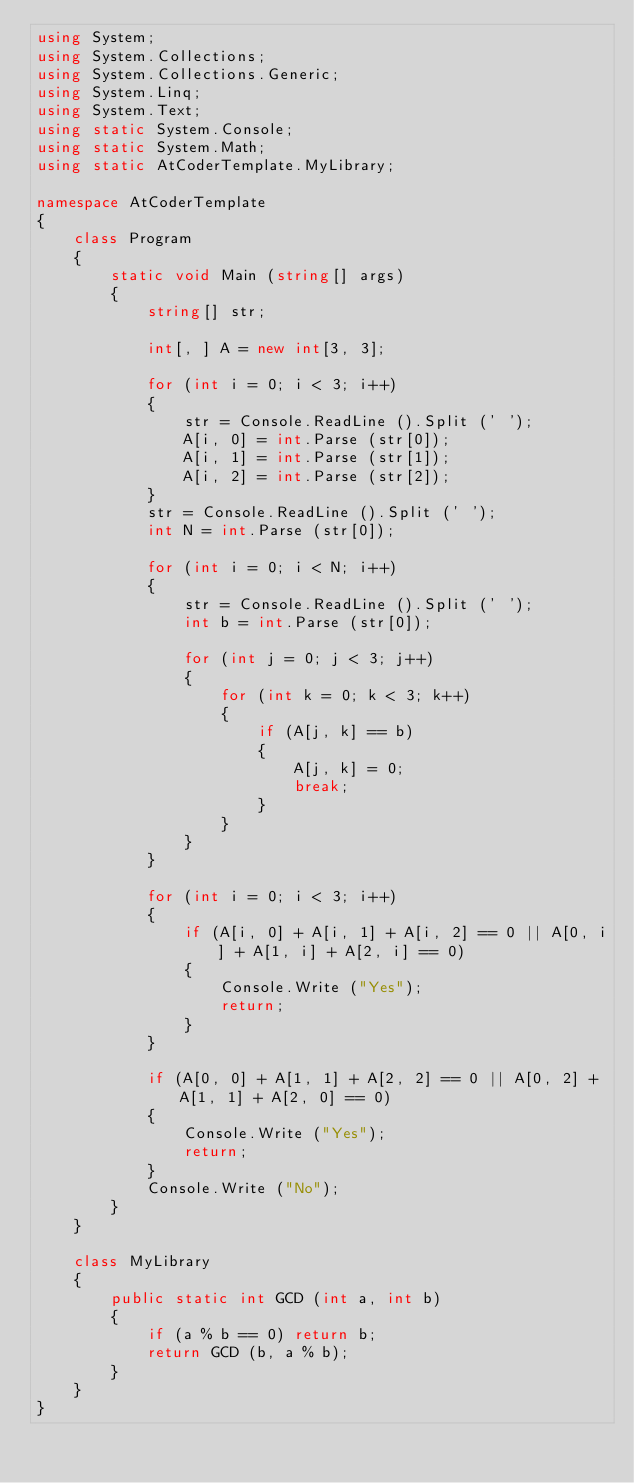Convert code to text. <code><loc_0><loc_0><loc_500><loc_500><_C#_>using System;
using System.Collections;
using System.Collections.Generic;
using System.Linq;
using System.Text;
using static System.Console;
using static System.Math;
using static AtCoderTemplate.MyLibrary;

namespace AtCoderTemplate
{
    class Program
    {
        static void Main (string[] args)
        {
            string[] str;

            int[, ] A = new int[3, 3];

            for (int i = 0; i < 3; i++)
            {
                str = Console.ReadLine ().Split (' ');
                A[i, 0] = int.Parse (str[0]);
                A[i, 1] = int.Parse (str[1]);
                A[i, 2] = int.Parse (str[2]);
            }
            str = Console.ReadLine ().Split (' ');
            int N = int.Parse (str[0]);

            for (int i = 0; i < N; i++)
            {
                str = Console.ReadLine ().Split (' ');
                int b = int.Parse (str[0]);

                for (int j = 0; j < 3; j++)
                {
                    for (int k = 0; k < 3; k++)
                    {
                        if (A[j, k] == b)
                        {
                            A[j, k] = 0;
                            break;
                        }
                    }
                }
            }

            for (int i = 0; i < 3; i++)
            {
                if (A[i, 0] + A[i, 1] + A[i, 2] == 0 || A[0, i] + A[1, i] + A[2, i] == 0)
                {
                    Console.Write ("Yes");
                    return;
                }
            }

            if (A[0, 0] + A[1, 1] + A[2, 2] == 0 || A[0, 2] + A[1, 1] + A[2, 0] == 0)
            {
                Console.Write ("Yes");
                return;
            }
            Console.Write ("No");
        }
    }

    class MyLibrary
    {
        public static int GCD (int a, int b)
        {
            if (a % b == 0) return b;
            return GCD (b, a % b);
        }
    }
}</code> 